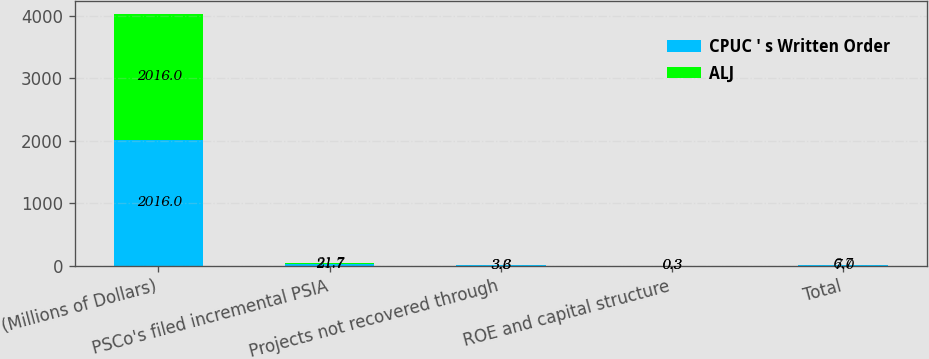Convert chart to OTSL. <chart><loc_0><loc_0><loc_500><loc_500><stacked_bar_chart><ecel><fcel>(Millions of Dollars)<fcel>PSCo's filed incremental PSIA<fcel>Projects not recovered through<fcel>ROE and capital structure<fcel>Total<nl><fcel>CPUC ' s Written Order<fcel>2016<fcel>21.7<fcel>3.6<fcel>0.3<fcel>7<nl><fcel>ALJ<fcel>2016<fcel>21.7<fcel>3.3<fcel>0.3<fcel>6.7<nl></chart> 